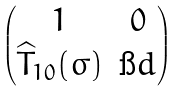<formula> <loc_0><loc_0><loc_500><loc_500>\begin{pmatrix} 1 & 0 \\ \widehat { T } _ { 1 0 } ( \sigma ) & \i d \end{pmatrix}</formula> 